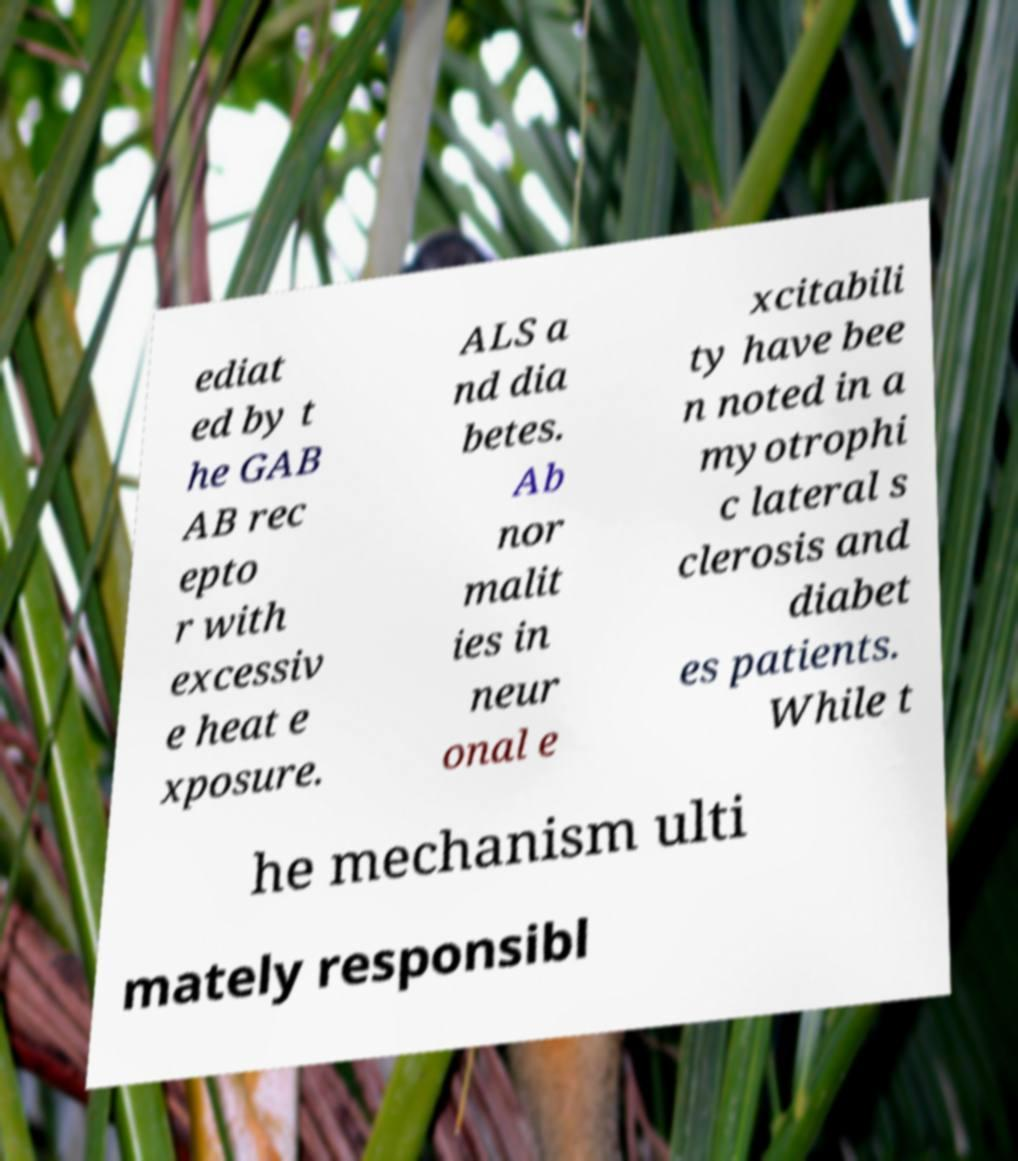There's text embedded in this image that I need extracted. Can you transcribe it verbatim? ediat ed by t he GAB AB rec epto r with excessiv e heat e xposure. ALS a nd dia betes. Ab nor malit ies in neur onal e xcitabili ty have bee n noted in a myotrophi c lateral s clerosis and diabet es patients. While t he mechanism ulti mately responsibl 